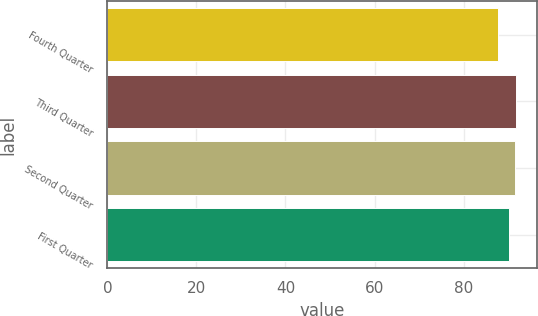Convert chart. <chart><loc_0><loc_0><loc_500><loc_500><bar_chart><fcel>Fourth Quarter<fcel>Third Quarter<fcel>Second Quarter<fcel>First Quarter<nl><fcel>87.69<fcel>91.87<fcel>91.47<fcel>90.11<nl></chart> 